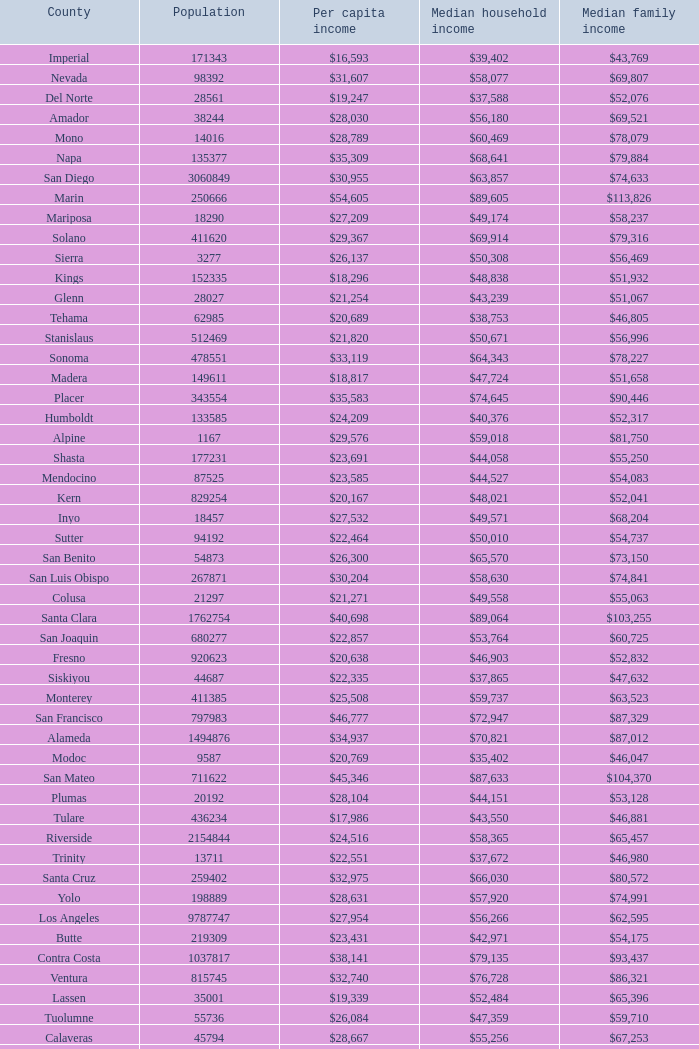What is the median household income of butte? $42,971. 